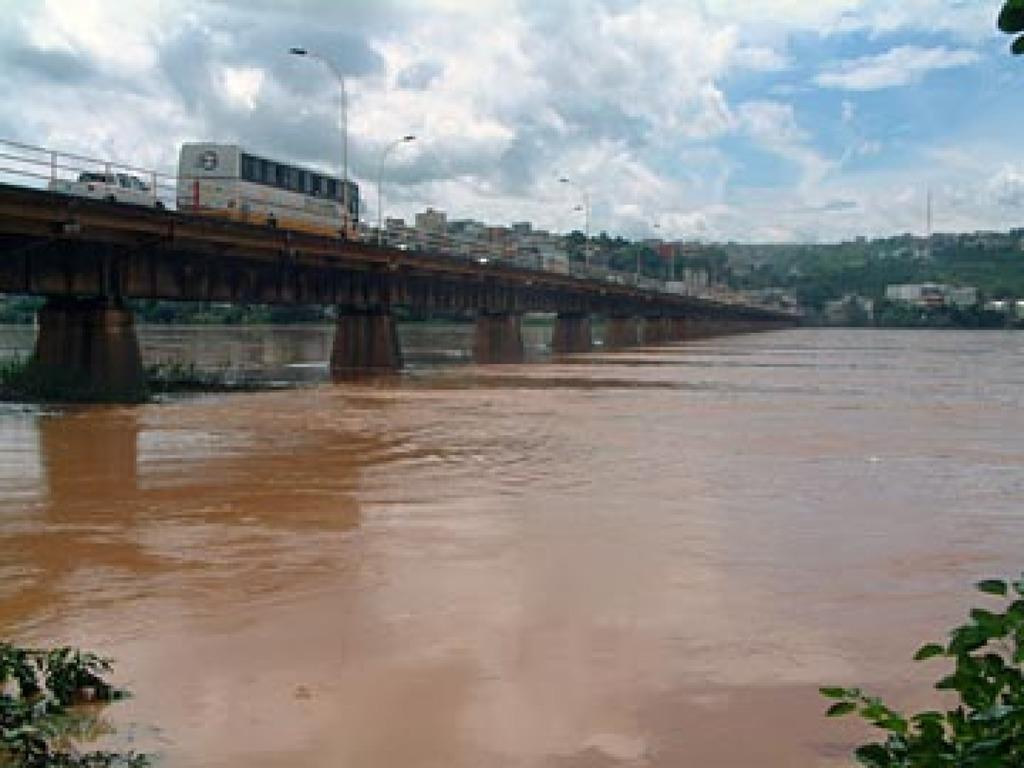What body of water is present in the image? There is a river in the image. How does the river appear to be crossed? There is a bridge over the river in the image. What is happening on the bridge? Vehicles are riding on the bridge. What can be seen in the distance behind the river? There is a mountain in the background of the image. Are there any structures on the mountain? Yes, there are buildings on the mountain. What type of camera is being used to capture the image? There is no information about the camera used to capture the image, as we are only looking at the image itself. 